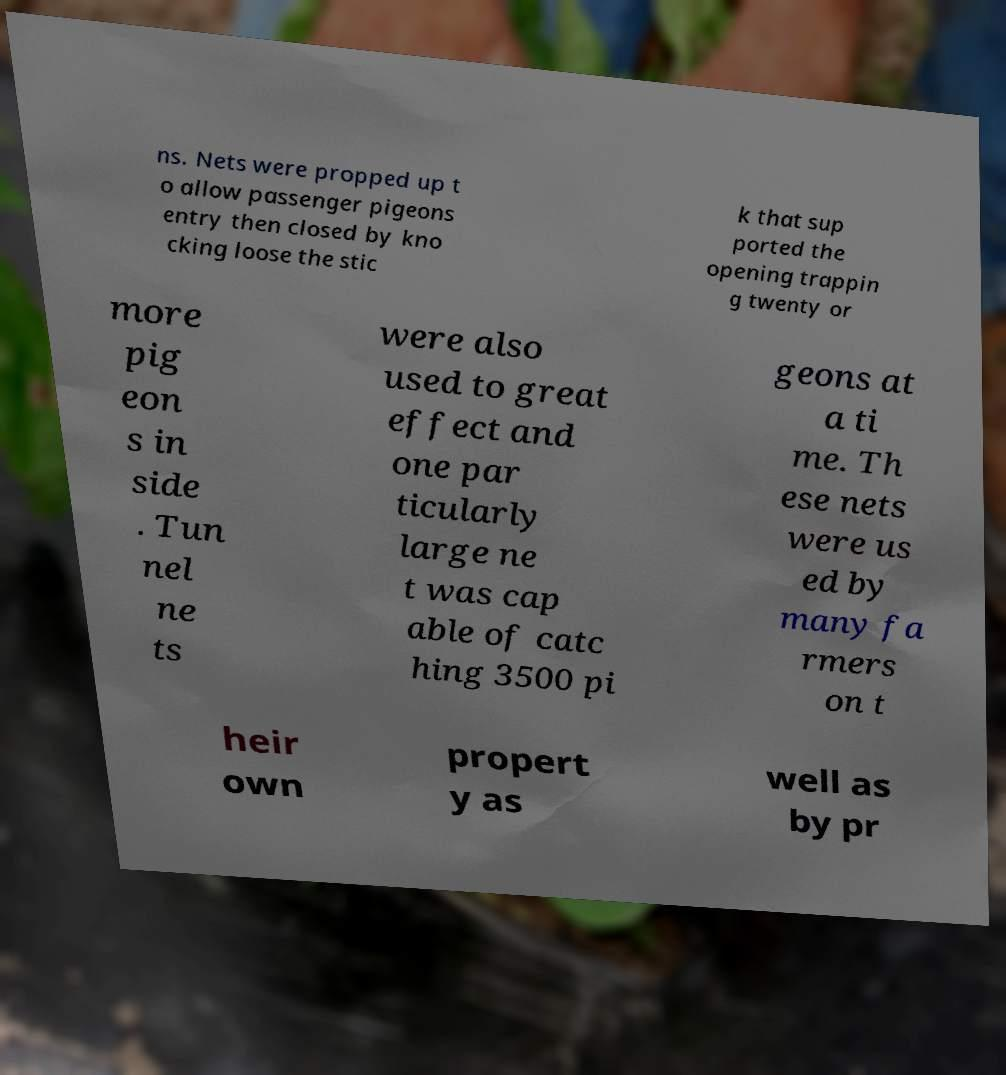Please read and relay the text visible in this image. What does it say? ns. Nets were propped up t o allow passenger pigeons entry then closed by kno cking loose the stic k that sup ported the opening trappin g twenty or more pig eon s in side . Tun nel ne ts were also used to great effect and one par ticularly large ne t was cap able of catc hing 3500 pi geons at a ti me. Th ese nets were us ed by many fa rmers on t heir own propert y as well as by pr 